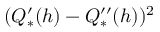<formula> <loc_0><loc_0><loc_500><loc_500>( Q _ { * } ^ { \prime } ( h ) - Q _ { * } ^ { \prime \prime } ( h ) ) ^ { 2 }</formula> 